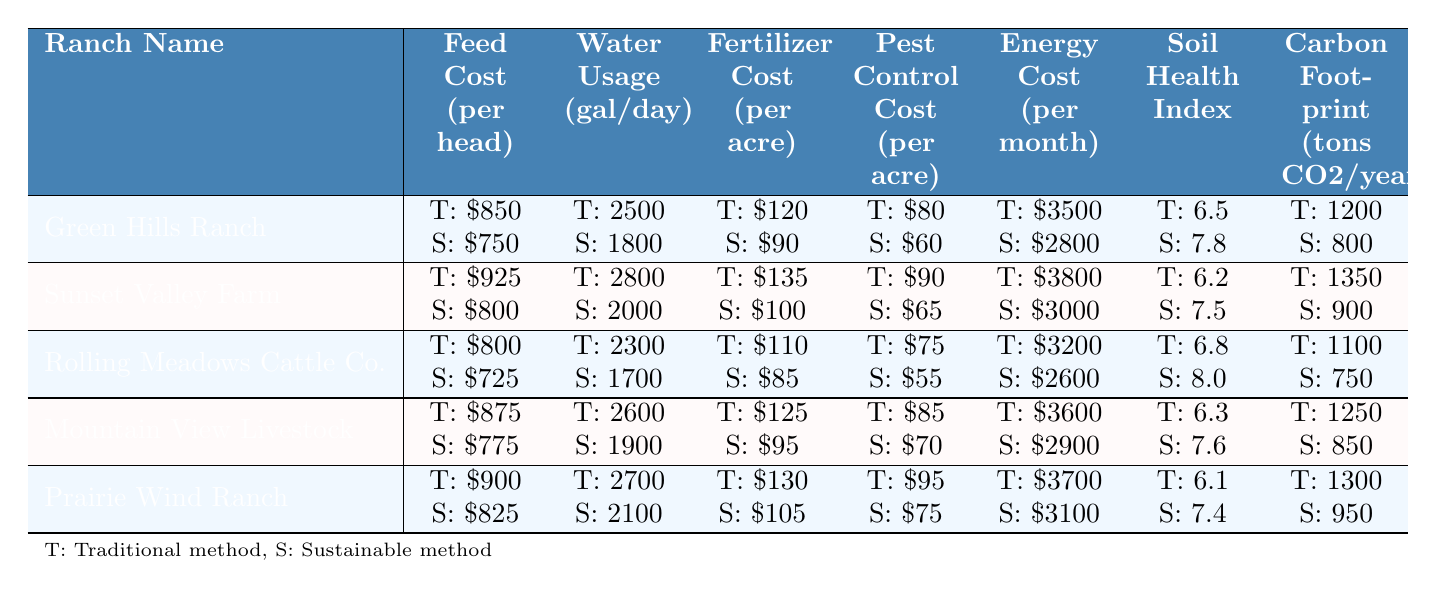What is the total traditional feed cost per head for all the ranches combined? Sum the traditional feed cost per head for all ranches: 850 + 925 + 800 + 875 + 900 = 4350
Answer: 4350 Which ranch has the lowest sustainable feed cost per head? The sustainable feed costs per head are 750, 800, 725, 775, and 825. The lowest is 725 at Rolling Meadows Cattle Co.
Answer: Rolling Meadows Cattle Co What is the difference in water usage per day between traditional and sustainable methods for Sunset Valley Farm? For Sunset Valley Farm, traditional water usage is 2800 gallons and sustainable is 2000 gallons. The difference is 2800 - 2000 = 800 gallons.
Answer: 800 gallons Which ranch has the highest score for sustainable animal welfare? The sustainable animal welfare scores are 8.8, 8.5, 9.0, 8.6, and 8.4. The highest score is 9.0 at Rolling Meadows Cattle Co.
Answer: Rolling Meadows Cattle Co What is the average traditional soil health index across all ranches? Sum the traditional soil health index values: 6.5 + 6.2 + 6.8 + 6.3 + 6.1 = 31.9. Then divide by 5 (number of ranches) to get the average: 31.9 / 5 = 6.38.
Answer: 6.38 Is the sustainable energy cost per month for Prairie Wind Ranch lower than that of Green Hills Ranch? The sustainable energy cost for Prairie Wind Ranch is 3100 and for Green Hills Ranch it is 2800. 3100 > 2800 means it is not lower.
Answer: No What is the total reduction in carbon footprint when comparing traditional and sustainable practices across all ranches? Calculate the total traditional carbon footprint: 1200 + 1350 + 1100 + 1250 + 1300 = 6350. Calculate the total sustainable carbon footprint: 800 + 900 + 750 + 850 + 950 = 4250. The reduction is 6350 - 4250 = 2100 tons CO2.
Answer: 2100 tons CO2 Which ranch shows the highest percentage decrease in pest control cost per acre when moving from traditional to sustainable practices? The percentage decrease in pest control cost for each ranch is calculated as: ((T - S)/T) * 100. For example, Green Hills Ranch: ((80 - 60)/80) * 100 = 25%. Calculate for all to find the highest percentage decrease, which is Mountain View Livestock at 17.65%.
Answer: Mountain View Livestock Which ranch experiences the least reduction in fertilizer cost per acre when moving to sustainable practices? The reductions in fertilizer costs are: Green Hills Ranch: 120 - 90 = 30, Sunset Valley Farm: 135 - 100 = 35, Rolling Meadows: 110 - 85 = 25, Mountain View: 125 - 95 = 30, Prairie Wind: 130 - 105 = 25. Sunset Valley Farm has the highest reduction cost.
Answer: Sunset Valley Farm For which ranch is the sustainable pest control cost 15% lower than the traditional cost? Calculate for each ranch using the formula: S = T * (1 - 0.15). For example, Green Hills Ranch: 80 * (1 - 0.15) = 68. The only ranch fitting this criterion is Rolling Meadows Cattle Co.
Answer: Rolling Meadows Cattle Co 